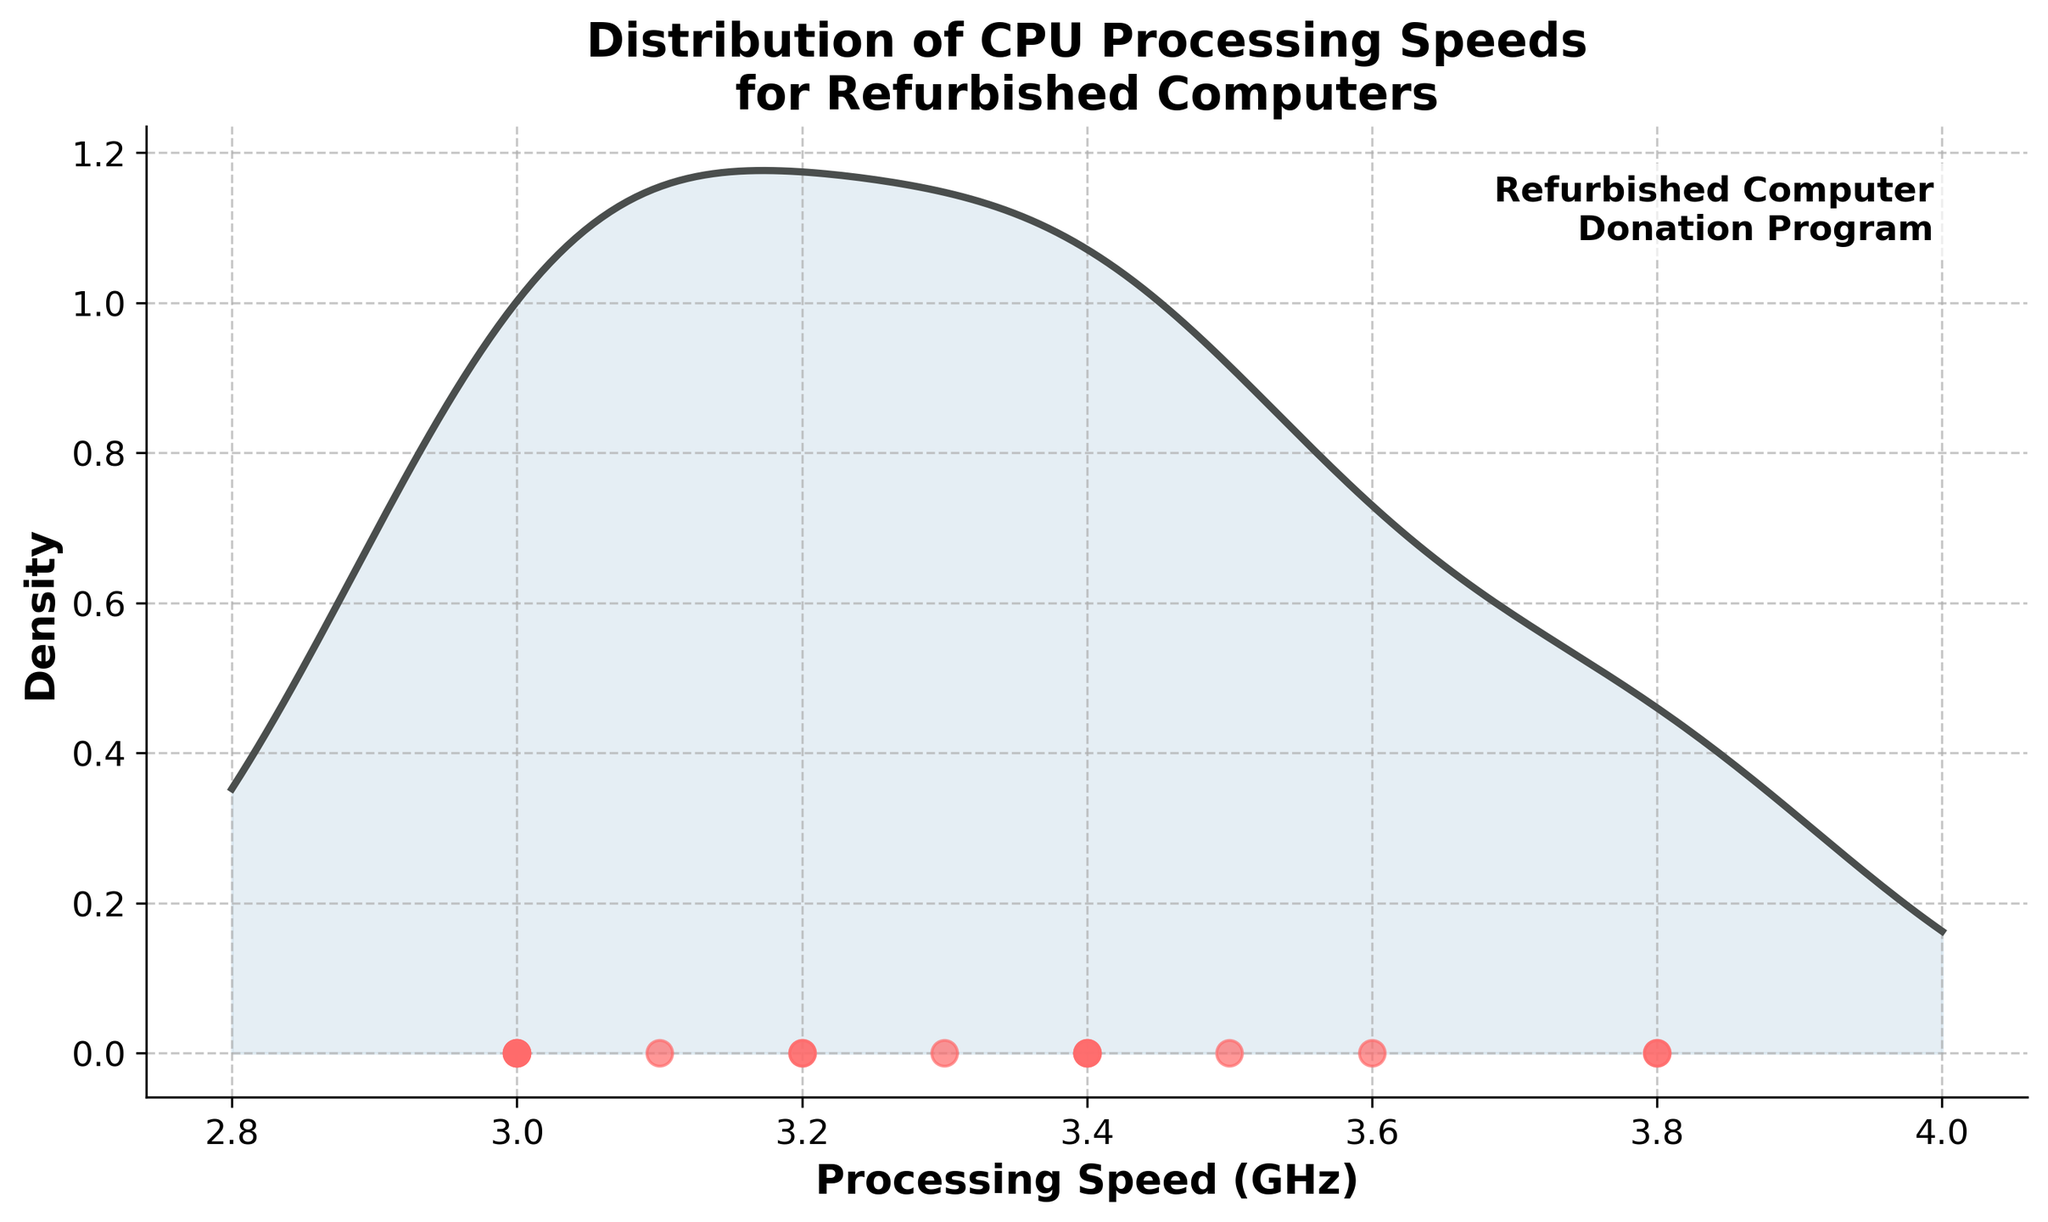How many CPUs are depicted in the density plot? To determine the number of CPUs, simply count the red-colored points on the x-axis. Each point represents a single CPU.
Answer: 15 What is the title of the plot? Look at the text at the top of the chart, which is conventionally used as the title.
Answer: Distribution of CPU Processing Speeds for Refurbished Computers What is the highest peak in the density plot? Observe the highest value on the y-axis where the curve reaches its maximum. This corresponds to the highest density of CPU processing speeds.
Answer: Around 3.0 GHz Which CPU model has the highest processing speed? Find the red-colored points on the x-axis and identify the one located farthest to the right. Then, refer to the correlating CPU model from the given data.
Answer: AMD A10-5800K What processing speeds have the lowest density in the plot? Identify the areas where the density curve is closest to the x-axis, i.e., the lowest peaks or troughs of the plot.
Answer: Approximately 3.6 GHz, 3.8 GHz How many different processing speed values are there? Count the unique values in the x-axis points where the red dots are located.
Answer: 8 Which processing speed lies exactly in the middle of the dataset? Arrange the processing speeds in order and find the median value, which is the middle value of the sorted list.
Answer: 3.2 GHz How does the density at 3.4 GHz compare to the density at 3.0 GHz? Observe the height of the density curve at both 3.4 GHz and 3.0 GHz on the x-axis and compare their values.
Answer: Lower at 3.4 GHz than at 3.0 GHz What does the shaded area under the density curve represent? The area under the density curve represents the probability density of the CPU processing speeds, indicating where the values are concentrated.
Answer: Probability density Is there any annotation on the plot? If so, what does it indicate? Look for any text annotations directly on the plot, which usually provide additional context or information.
Answer: Refurbished Computer Donation Program 